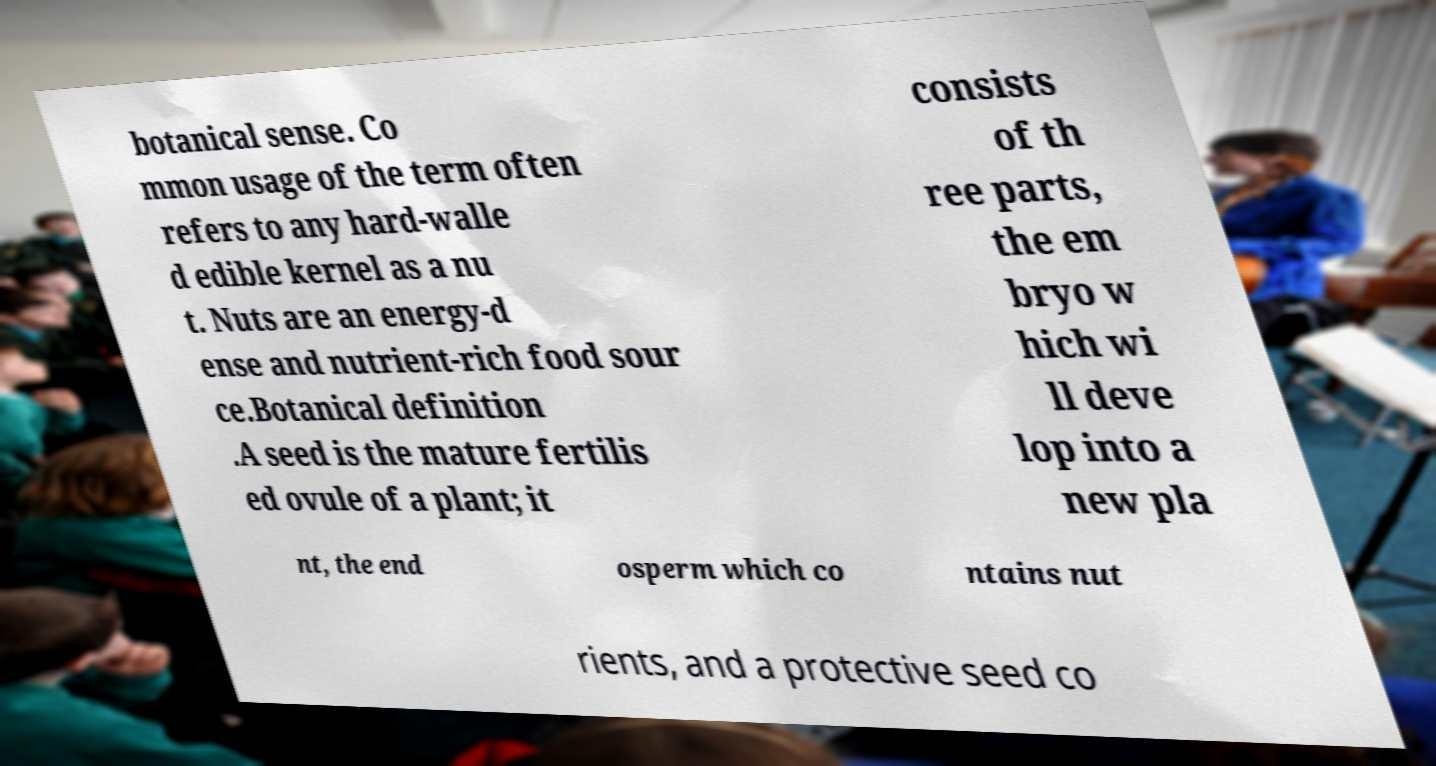Could you assist in decoding the text presented in this image and type it out clearly? botanical sense. Co mmon usage of the term often refers to any hard-walle d edible kernel as a nu t. Nuts are an energy-d ense and nutrient-rich food sour ce.Botanical definition .A seed is the mature fertilis ed ovule of a plant; it consists of th ree parts, the em bryo w hich wi ll deve lop into a new pla nt, the end osperm which co ntains nut rients, and a protective seed co 